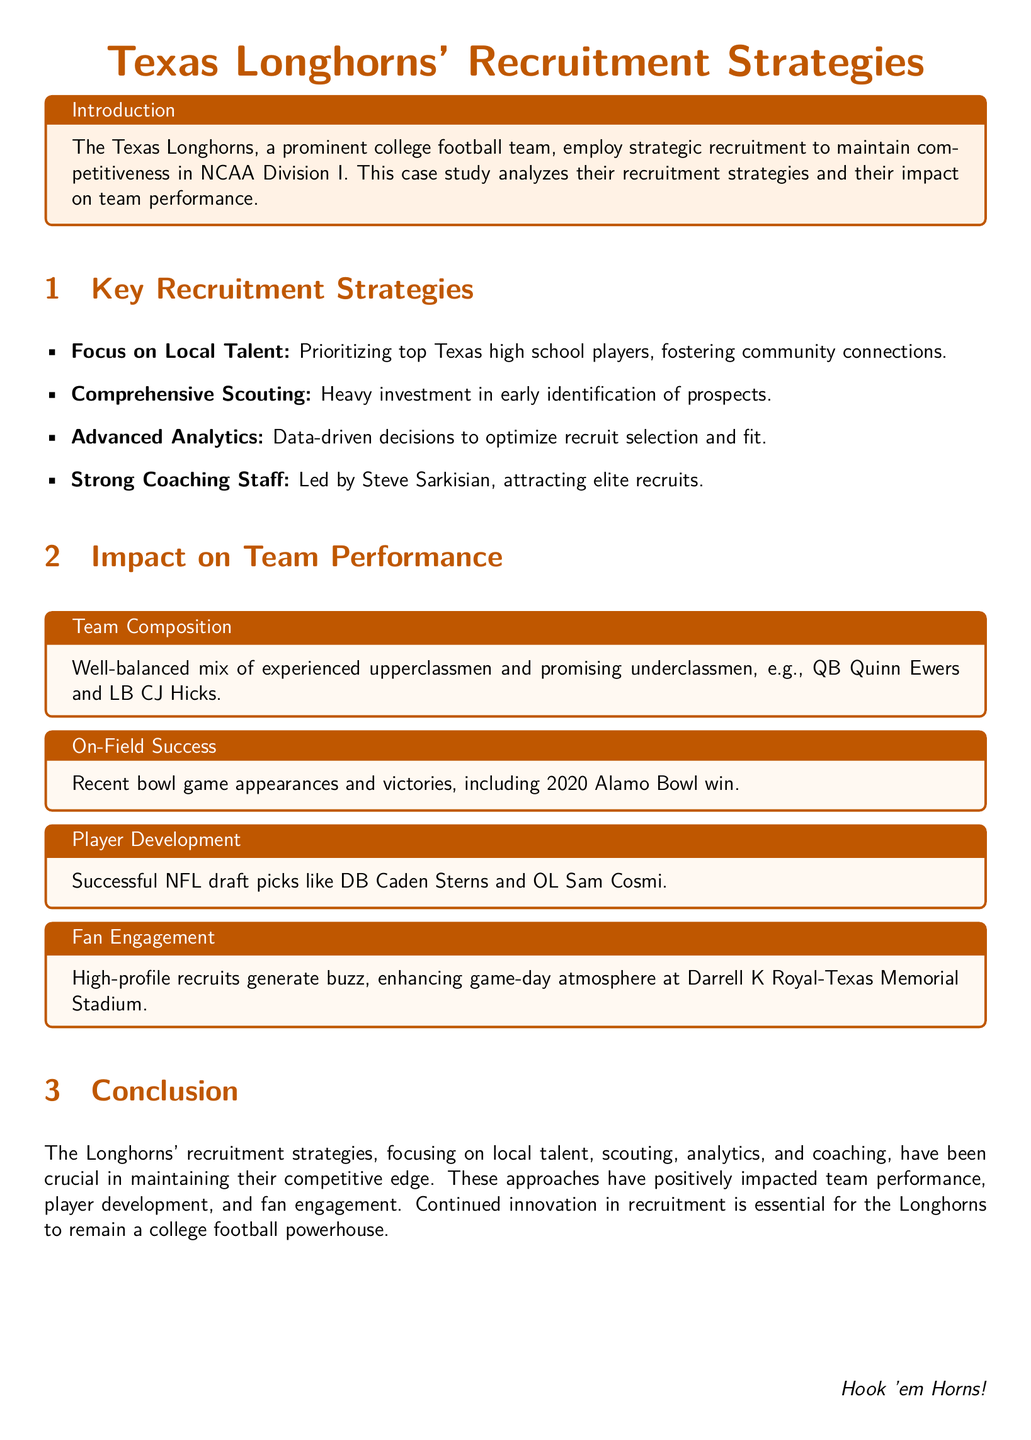What are the Texas Longhorns' recruitment strategies? The document lists key recruitment strategies employed by the Texas Longhorns, which include focusing on local talent, comprehensive scouting, advanced analytics, and having a strong coaching staff.
Answer: Focus on Local Talent, Comprehensive Scouting, Advanced Analytics, Strong Coaching Staff Who is the head coach mentioned in the document? The document highlights the head coaching of Steve Sarkisian as a key factor in attracting elite recruits.
Answer: Steve Sarkisian What was the outcome of the 2020 Alamo Bowl? The on-field success section of the document mentions a specific bowl game victory.
Answer: Win Name a successful NFL draft pick from the Longhorns. The document lists successful players who were drafted into the NFL, including Caden Sterns and Sam Cosmi.
Answer: Caden Sterns What type of athletes does Texas Longhorns prioritize in recruitment? The strategy emphasizes recruiting a specific group of athletes based on geographical location.
Answer: Top Texas high school players How does the fan engagement relate to recruitment? The document states that high-profile recruits generate excitement and enhance game-day atmosphere.
Answer: Enhancing game-day atmosphere What is the primary impact of recruitment strategies on team performance? The document connects recruitment strategies to several positive outcomes for the team.
Answer: Competitive edge How do advanced analytics contribute to recruit selection? The document indicates that data-driven decisions play an essential role in optimizing recruit selection.
Answer: Data-driven decisions What is emphasized alongside the combination of experienced and promising players? The document discusses the composition of the team, mentioning balance among player types.
Answer: Well-balanced mix 